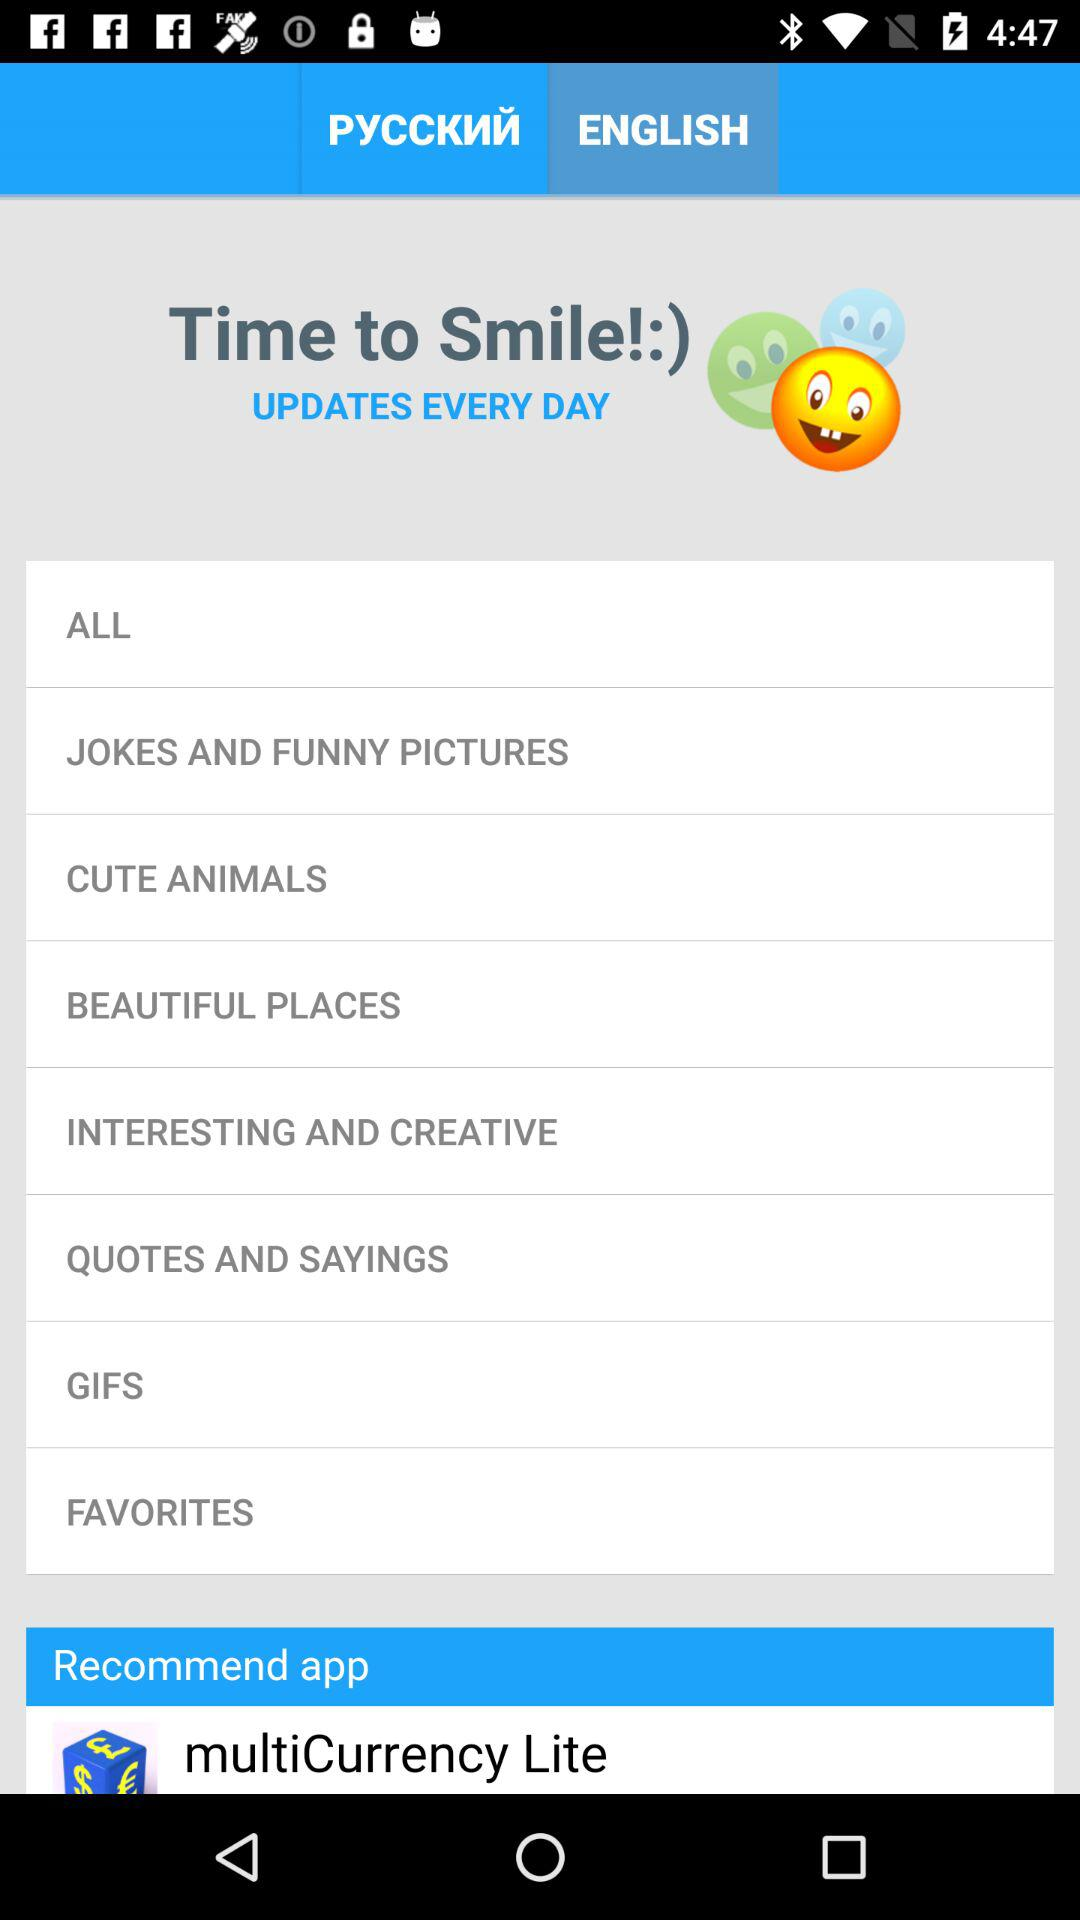Which tab am I using? You are using the "ENGLISH" tab. 